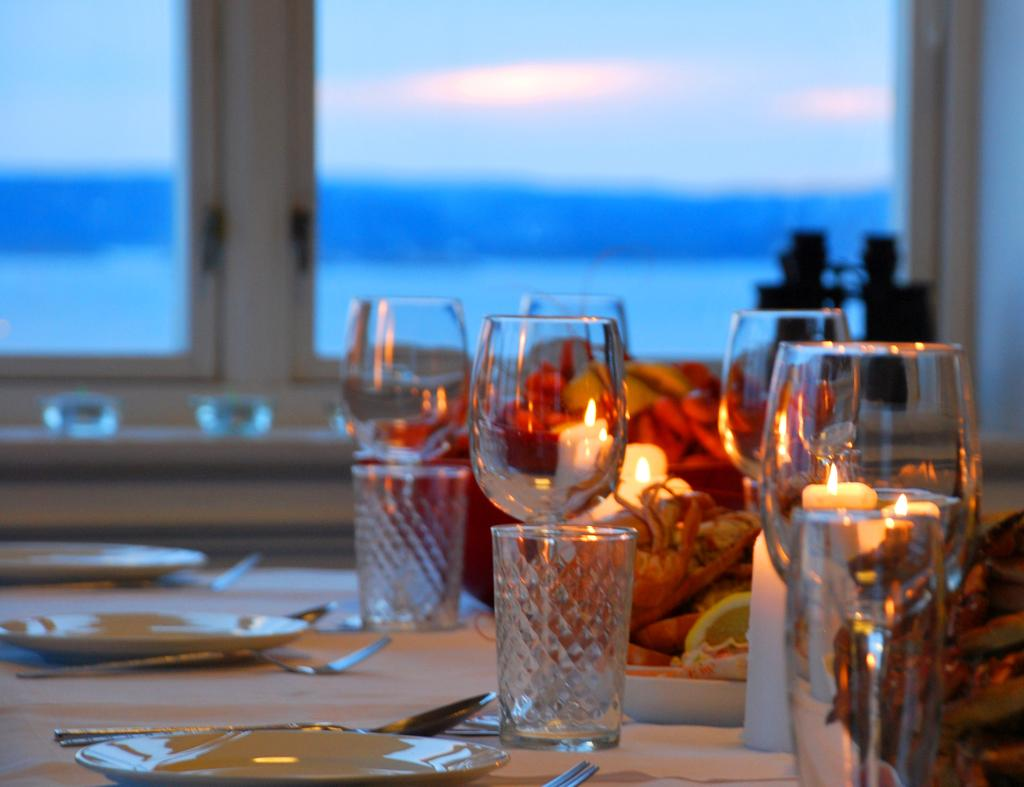What can be seen in the image that allows light to enter the room? There is a window in the image. What piece of furniture is present in the image? There is a table in the image. What items are on the table? There are plates, forks, glasses, and flowers on the table. What type of cheese is being served in the glasses on the table? There is no cheese present in the image; the glasses contain liquid, likely water or another beverage. Is eggnog being served in the plates on the table? There is no eggnog present in the image; the plates contain food, likely on the plates. 